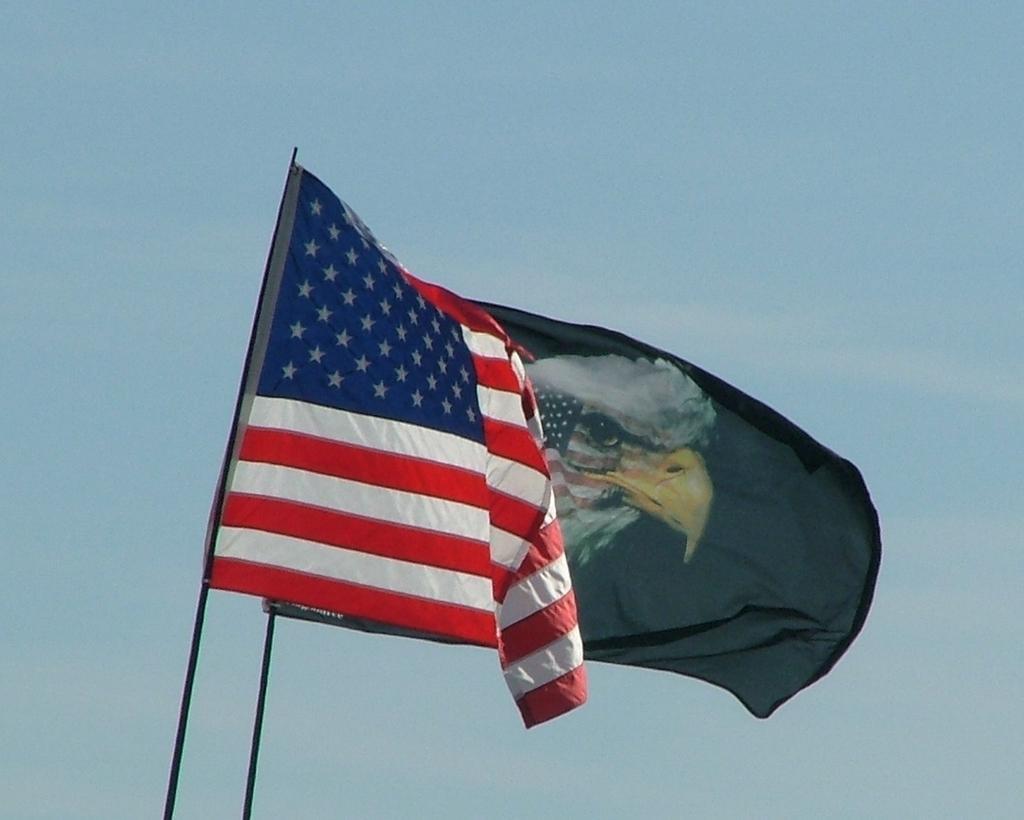Could you give a brief overview of what you see in this image? In the image there are two flags flying and above its sky with clouds. 